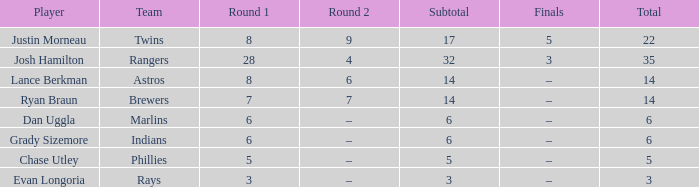In round 1, which player has a subtotal exceeding both 3 and 8? Josh Hamilton. 